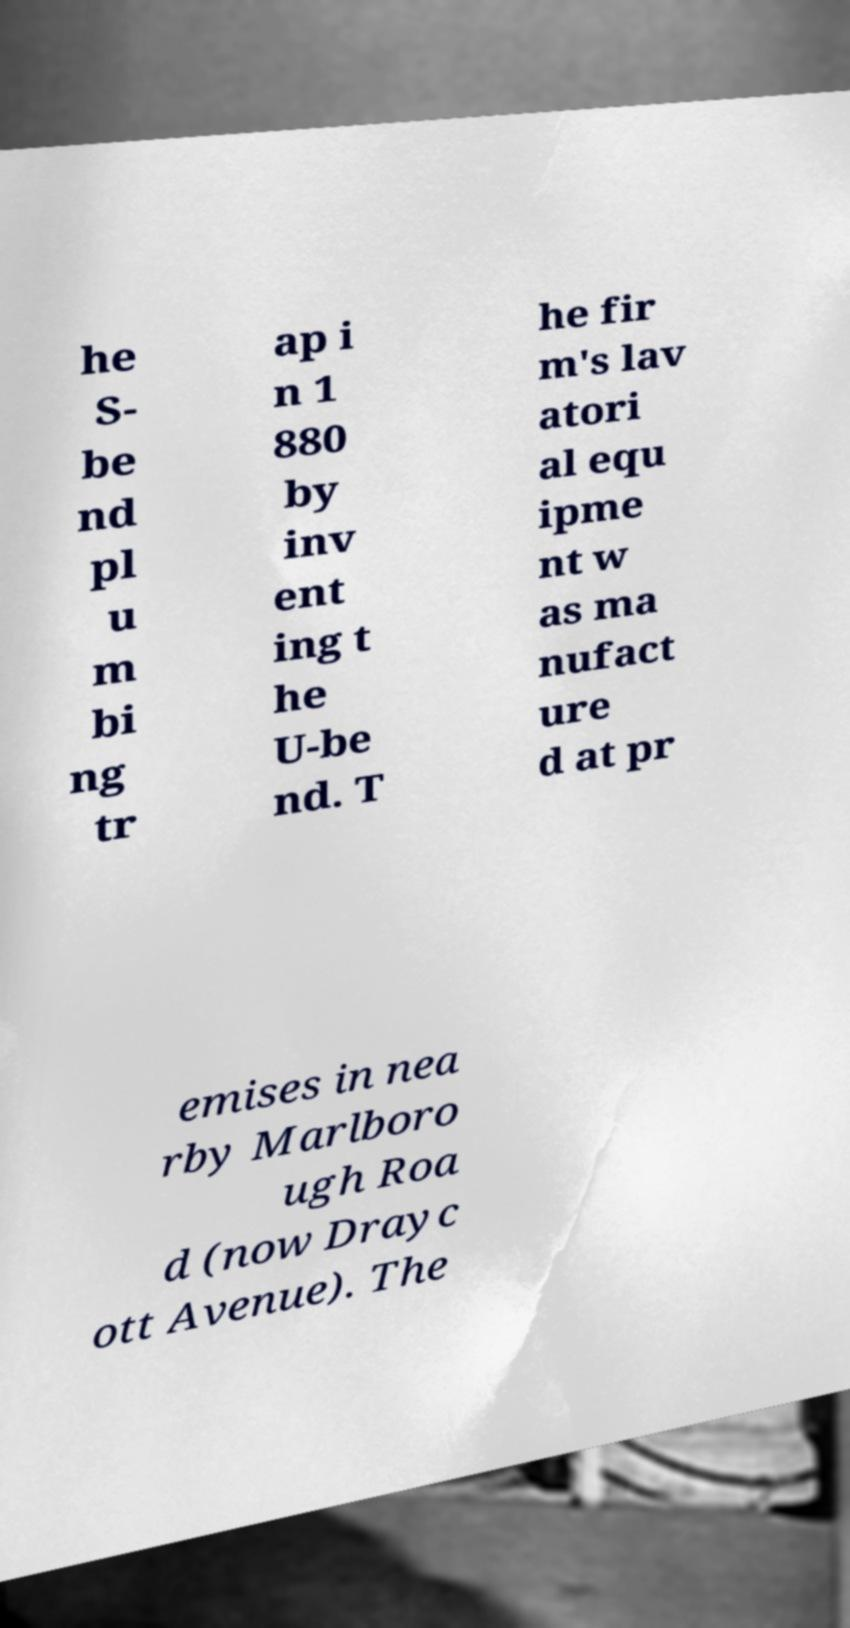Could you assist in decoding the text presented in this image and type it out clearly? he S- be nd pl u m bi ng tr ap i n 1 880 by inv ent ing t he U-be nd. T he fir m's lav atori al equ ipme nt w as ma nufact ure d at pr emises in nea rby Marlboro ugh Roa d (now Drayc ott Avenue). The 